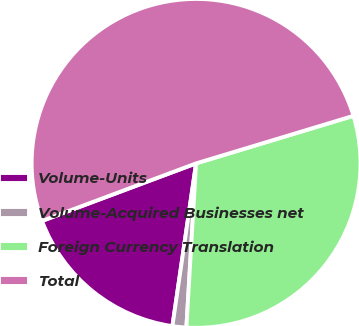<chart> <loc_0><loc_0><loc_500><loc_500><pie_chart><fcel>Volume-Units<fcel>Volume-Acquired Businesses net<fcel>Foreign Currency Translation<fcel>Total<nl><fcel>17.01%<fcel>1.36%<fcel>30.61%<fcel>51.02%<nl></chart> 